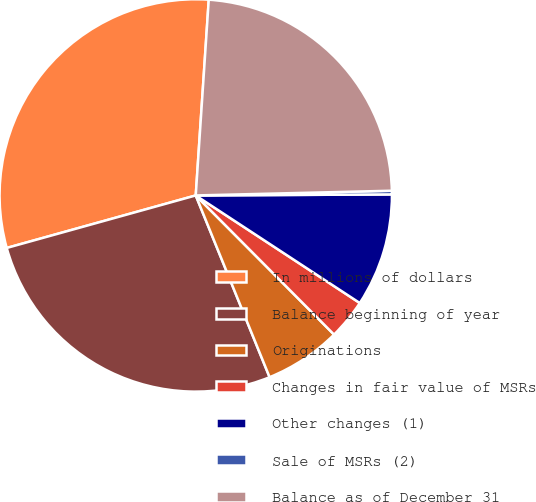<chart> <loc_0><loc_0><loc_500><loc_500><pie_chart><fcel>In millions of dollars<fcel>Balance beginning of year<fcel>Originations<fcel>Changes in fair value of MSRs<fcel>Other changes (1)<fcel>Sale of MSRs (2)<fcel>Balance as of December 31<nl><fcel>30.37%<fcel>26.83%<fcel>6.31%<fcel>3.31%<fcel>9.32%<fcel>0.3%<fcel>23.56%<nl></chart> 